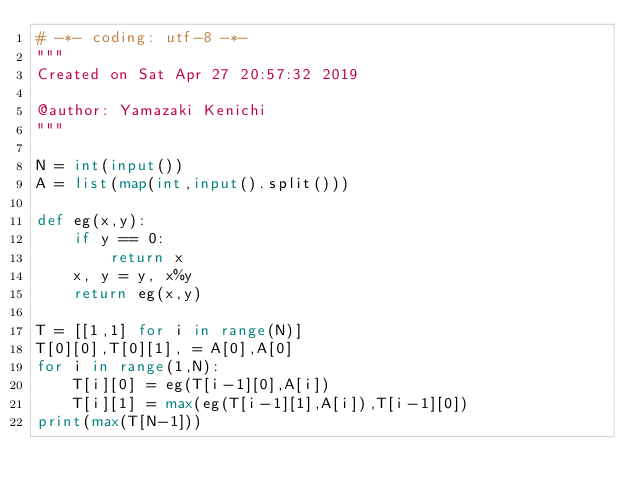<code> <loc_0><loc_0><loc_500><loc_500><_Python_># -*- coding: utf-8 -*-
"""
Created on Sat Apr 27 20:57:32 2019

@author: Yamazaki Kenichi
"""

N = int(input())
A = list(map(int,input().split()))

def eg(x,y):
    if y == 0:
        return x
    x, y = y, x%y
    return eg(x,y)

T = [[1,1] for i in range(N)]
T[0][0],T[0][1], = A[0],A[0]
for i in range(1,N):
    T[i][0] = eg(T[i-1][0],A[i])
    T[i][1] = max(eg(T[i-1][1],A[i]),T[i-1][0])
print(max(T[N-1]))</code> 